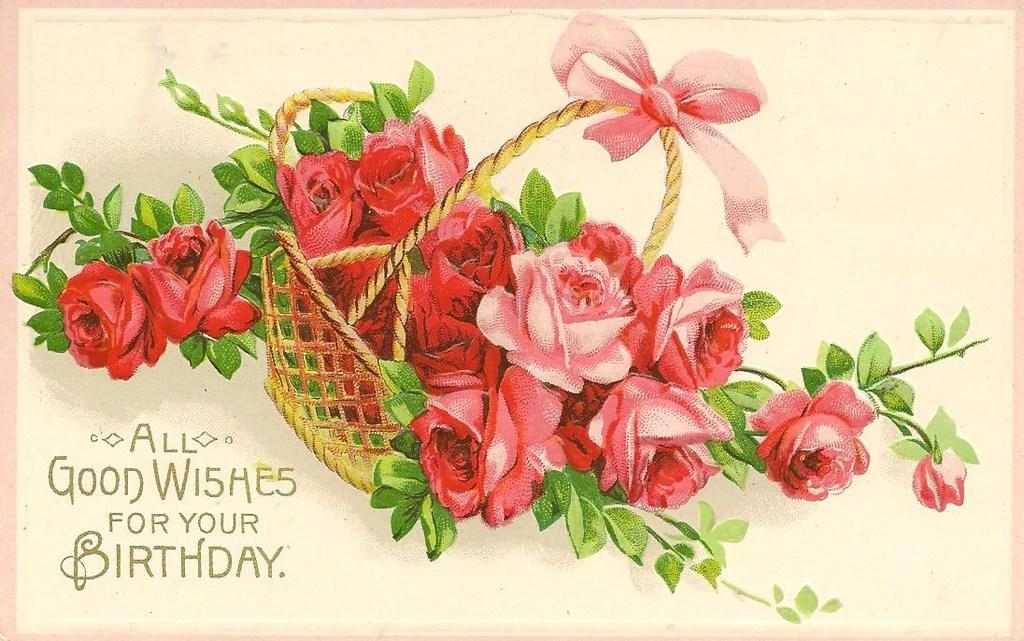Can you describe this image briefly? This is a card and on it we can see plants and flowers in a basket and on the left side at the bottom corner we can see text written on it. 